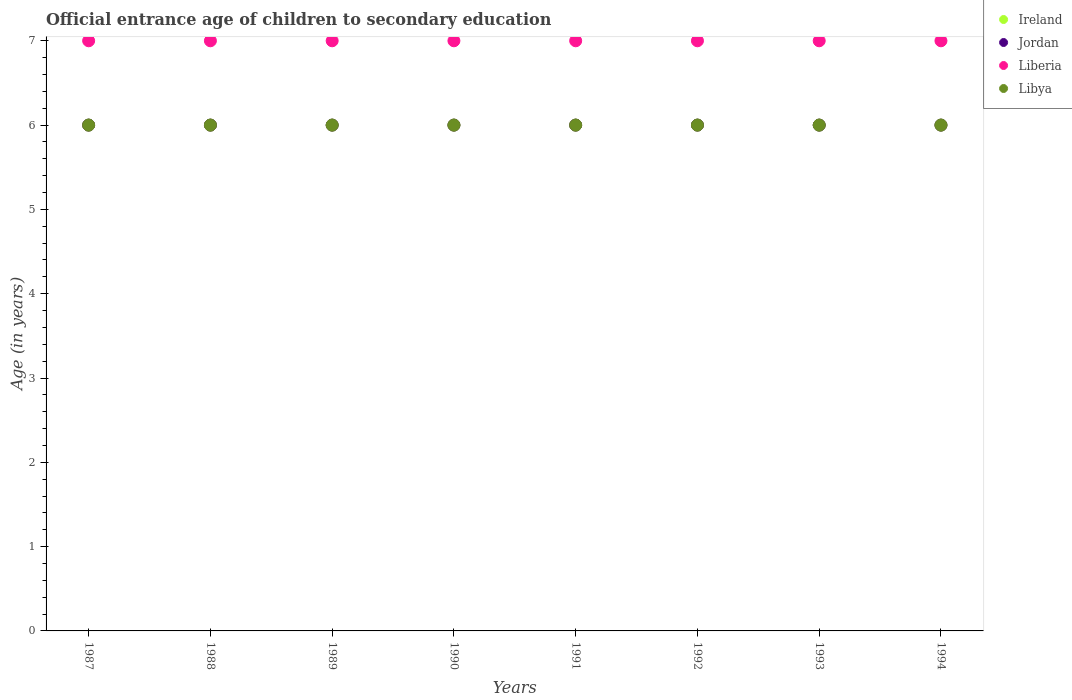What is the secondary school starting age of children in Liberia in 1988?
Provide a succinct answer. 7. Across all years, what is the maximum secondary school starting age of children in Liberia?
Keep it short and to the point. 7. Across all years, what is the minimum secondary school starting age of children in Jordan?
Ensure brevity in your answer.  6. In which year was the secondary school starting age of children in Liberia minimum?
Give a very brief answer. 1987. What is the total secondary school starting age of children in Ireland in the graph?
Make the answer very short. 48. What is the difference between the secondary school starting age of children in Jordan in 1989 and that in 1991?
Offer a very short reply. 0. What is the difference between the secondary school starting age of children in Jordan in 1992 and the secondary school starting age of children in Libya in 1994?
Your answer should be compact. 0. What is the average secondary school starting age of children in Jordan per year?
Your answer should be compact. 6. In the year 1989, what is the difference between the secondary school starting age of children in Jordan and secondary school starting age of children in Ireland?
Ensure brevity in your answer.  0. In how many years, is the secondary school starting age of children in Jordan greater than 4.8 years?
Give a very brief answer. 8. What is the difference between the highest and the lowest secondary school starting age of children in Ireland?
Ensure brevity in your answer.  0. In how many years, is the secondary school starting age of children in Libya greater than the average secondary school starting age of children in Libya taken over all years?
Provide a succinct answer. 0. Is the sum of the secondary school starting age of children in Jordan in 1987 and 1989 greater than the maximum secondary school starting age of children in Liberia across all years?
Provide a short and direct response. Yes. Does the secondary school starting age of children in Libya monotonically increase over the years?
Ensure brevity in your answer.  No. Is the secondary school starting age of children in Libya strictly greater than the secondary school starting age of children in Ireland over the years?
Ensure brevity in your answer.  No. Is the secondary school starting age of children in Jordan strictly less than the secondary school starting age of children in Libya over the years?
Provide a succinct answer. No. How many years are there in the graph?
Offer a very short reply. 8. Are the values on the major ticks of Y-axis written in scientific E-notation?
Keep it short and to the point. No. What is the title of the graph?
Ensure brevity in your answer.  Official entrance age of children to secondary education. Does "Greece" appear as one of the legend labels in the graph?
Provide a short and direct response. No. What is the label or title of the Y-axis?
Provide a short and direct response. Age (in years). What is the Age (in years) of Ireland in 1987?
Provide a short and direct response. 6. What is the Age (in years) in Liberia in 1988?
Your response must be concise. 7. What is the Age (in years) of Ireland in 1989?
Your answer should be very brief. 6. What is the Age (in years) in Liberia in 1990?
Offer a very short reply. 7. What is the Age (in years) in Libya in 1990?
Offer a very short reply. 6. What is the Age (in years) of Ireland in 1991?
Provide a succinct answer. 6. What is the Age (in years) of Liberia in 1991?
Keep it short and to the point. 7. What is the Age (in years) in Ireland in 1992?
Make the answer very short. 6. What is the Age (in years) in Jordan in 1992?
Offer a terse response. 6. What is the Age (in years) of Liberia in 1992?
Your answer should be very brief. 7. What is the Age (in years) in Libya in 1992?
Give a very brief answer. 6. What is the Age (in years) of Jordan in 1993?
Ensure brevity in your answer.  6. What is the Age (in years) in Libya in 1993?
Provide a succinct answer. 6. What is the Age (in years) of Jordan in 1994?
Keep it short and to the point. 6. Across all years, what is the maximum Age (in years) in Ireland?
Offer a terse response. 6. Across all years, what is the maximum Age (in years) of Jordan?
Your answer should be very brief. 6. Across all years, what is the maximum Age (in years) of Libya?
Ensure brevity in your answer.  6. Across all years, what is the minimum Age (in years) in Ireland?
Your answer should be compact. 6. What is the total Age (in years) of Ireland in the graph?
Your answer should be very brief. 48. What is the total Age (in years) of Jordan in the graph?
Make the answer very short. 48. What is the difference between the Age (in years) in Jordan in 1987 and that in 1988?
Keep it short and to the point. 0. What is the difference between the Age (in years) in Libya in 1987 and that in 1988?
Your response must be concise. 0. What is the difference between the Age (in years) of Ireland in 1987 and that in 1989?
Keep it short and to the point. 0. What is the difference between the Age (in years) in Jordan in 1987 and that in 1989?
Ensure brevity in your answer.  0. What is the difference between the Age (in years) of Liberia in 1987 and that in 1990?
Offer a terse response. 0. What is the difference between the Age (in years) of Libya in 1987 and that in 1990?
Offer a very short reply. 0. What is the difference between the Age (in years) in Libya in 1987 and that in 1991?
Your answer should be very brief. 0. What is the difference between the Age (in years) in Jordan in 1987 and that in 1992?
Provide a succinct answer. 0. What is the difference between the Age (in years) of Liberia in 1987 and that in 1992?
Your answer should be very brief. 0. What is the difference between the Age (in years) of Libya in 1987 and that in 1992?
Your response must be concise. 0. What is the difference between the Age (in years) in Jordan in 1987 and that in 1993?
Give a very brief answer. 0. What is the difference between the Age (in years) in Liberia in 1987 and that in 1993?
Your answer should be very brief. 0. What is the difference between the Age (in years) of Libya in 1987 and that in 1993?
Offer a terse response. 0. What is the difference between the Age (in years) in Ireland in 1987 and that in 1994?
Offer a very short reply. 0. What is the difference between the Age (in years) in Liberia in 1988 and that in 1989?
Keep it short and to the point. 0. What is the difference between the Age (in years) in Jordan in 1988 and that in 1990?
Your answer should be very brief. 0. What is the difference between the Age (in years) in Ireland in 1988 and that in 1991?
Keep it short and to the point. 0. What is the difference between the Age (in years) of Libya in 1988 and that in 1991?
Keep it short and to the point. 0. What is the difference between the Age (in years) of Liberia in 1988 and that in 1992?
Your answer should be compact. 0. What is the difference between the Age (in years) in Jordan in 1988 and that in 1993?
Your response must be concise. 0. What is the difference between the Age (in years) of Ireland in 1988 and that in 1994?
Keep it short and to the point. 0. What is the difference between the Age (in years) in Jordan in 1988 and that in 1994?
Give a very brief answer. 0. What is the difference between the Age (in years) in Liberia in 1988 and that in 1994?
Your answer should be very brief. 0. What is the difference between the Age (in years) in Ireland in 1989 and that in 1990?
Keep it short and to the point. 0. What is the difference between the Age (in years) of Jordan in 1989 and that in 1990?
Your answer should be very brief. 0. What is the difference between the Age (in years) of Liberia in 1989 and that in 1990?
Provide a short and direct response. 0. What is the difference between the Age (in years) of Libya in 1989 and that in 1990?
Make the answer very short. 0. What is the difference between the Age (in years) in Jordan in 1989 and that in 1991?
Offer a terse response. 0. What is the difference between the Age (in years) in Ireland in 1989 and that in 1992?
Provide a short and direct response. 0. What is the difference between the Age (in years) of Ireland in 1990 and that in 1991?
Give a very brief answer. 0. What is the difference between the Age (in years) in Ireland in 1990 and that in 1992?
Make the answer very short. 0. What is the difference between the Age (in years) in Liberia in 1990 and that in 1992?
Offer a very short reply. 0. What is the difference between the Age (in years) in Jordan in 1990 and that in 1993?
Offer a very short reply. 0. What is the difference between the Age (in years) in Ireland in 1990 and that in 1994?
Give a very brief answer. 0. What is the difference between the Age (in years) in Liberia in 1991 and that in 1992?
Make the answer very short. 0. What is the difference between the Age (in years) of Ireland in 1991 and that in 1994?
Your answer should be compact. 0. What is the difference between the Age (in years) of Liberia in 1991 and that in 1994?
Provide a succinct answer. 0. What is the difference between the Age (in years) in Ireland in 1992 and that in 1993?
Ensure brevity in your answer.  0. What is the difference between the Age (in years) in Jordan in 1992 and that in 1994?
Offer a terse response. 0. What is the difference between the Age (in years) in Libya in 1992 and that in 1994?
Your answer should be very brief. 0. What is the difference between the Age (in years) of Liberia in 1993 and that in 1994?
Provide a short and direct response. 0. What is the difference between the Age (in years) of Ireland in 1987 and the Age (in years) of Jordan in 1988?
Provide a short and direct response. 0. What is the difference between the Age (in years) in Jordan in 1987 and the Age (in years) in Liberia in 1988?
Your response must be concise. -1. What is the difference between the Age (in years) of Jordan in 1987 and the Age (in years) of Libya in 1988?
Offer a terse response. 0. What is the difference between the Age (in years) of Ireland in 1987 and the Age (in years) of Liberia in 1989?
Give a very brief answer. -1. What is the difference between the Age (in years) of Ireland in 1987 and the Age (in years) of Libya in 1989?
Ensure brevity in your answer.  0. What is the difference between the Age (in years) in Jordan in 1987 and the Age (in years) in Liberia in 1989?
Your answer should be compact. -1. What is the difference between the Age (in years) of Jordan in 1987 and the Age (in years) of Liberia in 1990?
Your response must be concise. -1. What is the difference between the Age (in years) in Jordan in 1987 and the Age (in years) in Libya in 1990?
Offer a very short reply. 0. What is the difference between the Age (in years) in Liberia in 1987 and the Age (in years) in Libya in 1990?
Keep it short and to the point. 1. What is the difference between the Age (in years) of Ireland in 1987 and the Age (in years) of Jordan in 1991?
Give a very brief answer. 0. What is the difference between the Age (in years) of Ireland in 1987 and the Age (in years) of Libya in 1991?
Your answer should be very brief. 0. What is the difference between the Age (in years) of Jordan in 1987 and the Age (in years) of Liberia in 1991?
Make the answer very short. -1. What is the difference between the Age (in years) in Jordan in 1987 and the Age (in years) in Libya in 1991?
Your response must be concise. 0. What is the difference between the Age (in years) in Liberia in 1987 and the Age (in years) in Libya in 1991?
Your answer should be very brief. 1. What is the difference between the Age (in years) in Ireland in 1987 and the Age (in years) in Liberia in 1992?
Your answer should be compact. -1. What is the difference between the Age (in years) in Liberia in 1987 and the Age (in years) in Libya in 1992?
Offer a terse response. 1. What is the difference between the Age (in years) in Ireland in 1987 and the Age (in years) in Liberia in 1993?
Give a very brief answer. -1. What is the difference between the Age (in years) of Ireland in 1987 and the Age (in years) of Libya in 1993?
Ensure brevity in your answer.  0. What is the difference between the Age (in years) in Jordan in 1987 and the Age (in years) in Liberia in 1993?
Give a very brief answer. -1. What is the difference between the Age (in years) of Ireland in 1987 and the Age (in years) of Jordan in 1994?
Make the answer very short. 0. What is the difference between the Age (in years) of Ireland in 1987 and the Age (in years) of Liberia in 1994?
Provide a succinct answer. -1. What is the difference between the Age (in years) of Ireland in 1987 and the Age (in years) of Libya in 1994?
Ensure brevity in your answer.  0. What is the difference between the Age (in years) in Jordan in 1987 and the Age (in years) in Libya in 1994?
Provide a short and direct response. 0. What is the difference between the Age (in years) in Ireland in 1988 and the Age (in years) in Liberia in 1989?
Provide a succinct answer. -1. What is the difference between the Age (in years) in Ireland in 1988 and the Age (in years) in Libya in 1989?
Keep it short and to the point. 0. What is the difference between the Age (in years) of Jordan in 1988 and the Age (in years) of Libya in 1989?
Offer a terse response. 0. What is the difference between the Age (in years) in Liberia in 1988 and the Age (in years) in Libya in 1989?
Keep it short and to the point. 1. What is the difference between the Age (in years) of Ireland in 1988 and the Age (in years) of Jordan in 1990?
Your answer should be very brief. 0. What is the difference between the Age (in years) in Ireland in 1988 and the Age (in years) in Libya in 1990?
Make the answer very short. 0. What is the difference between the Age (in years) of Jordan in 1988 and the Age (in years) of Liberia in 1990?
Your answer should be very brief. -1. What is the difference between the Age (in years) of Jordan in 1988 and the Age (in years) of Libya in 1990?
Provide a short and direct response. 0. What is the difference between the Age (in years) of Ireland in 1988 and the Age (in years) of Jordan in 1991?
Offer a very short reply. 0. What is the difference between the Age (in years) in Ireland in 1988 and the Age (in years) in Liberia in 1991?
Give a very brief answer. -1. What is the difference between the Age (in years) in Ireland in 1988 and the Age (in years) in Libya in 1991?
Your response must be concise. 0. What is the difference between the Age (in years) of Jordan in 1988 and the Age (in years) of Liberia in 1991?
Your response must be concise. -1. What is the difference between the Age (in years) of Jordan in 1988 and the Age (in years) of Libya in 1991?
Offer a terse response. 0. What is the difference between the Age (in years) of Liberia in 1988 and the Age (in years) of Libya in 1991?
Offer a very short reply. 1. What is the difference between the Age (in years) of Jordan in 1988 and the Age (in years) of Liberia in 1992?
Provide a short and direct response. -1. What is the difference between the Age (in years) in Jordan in 1988 and the Age (in years) in Libya in 1992?
Offer a terse response. 0. What is the difference between the Age (in years) of Ireland in 1988 and the Age (in years) of Liberia in 1993?
Your answer should be compact. -1. What is the difference between the Age (in years) of Ireland in 1988 and the Age (in years) of Liberia in 1994?
Your response must be concise. -1. What is the difference between the Age (in years) in Ireland in 1988 and the Age (in years) in Libya in 1994?
Ensure brevity in your answer.  0. What is the difference between the Age (in years) in Jordan in 1988 and the Age (in years) in Liberia in 1994?
Your answer should be compact. -1. What is the difference between the Age (in years) in Jordan in 1988 and the Age (in years) in Libya in 1994?
Provide a short and direct response. 0. What is the difference between the Age (in years) of Liberia in 1988 and the Age (in years) of Libya in 1994?
Keep it short and to the point. 1. What is the difference between the Age (in years) of Ireland in 1989 and the Age (in years) of Jordan in 1990?
Provide a succinct answer. 0. What is the difference between the Age (in years) of Ireland in 1989 and the Age (in years) of Liberia in 1990?
Offer a terse response. -1. What is the difference between the Age (in years) in Ireland in 1989 and the Age (in years) in Libya in 1990?
Your answer should be very brief. 0. What is the difference between the Age (in years) in Jordan in 1989 and the Age (in years) in Liberia in 1990?
Your answer should be compact. -1. What is the difference between the Age (in years) of Jordan in 1989 and the Age (in years) of Libya in 1990?
Offer a terse response. 0. What is the difference between the Age (in years) in Jordan in 1989 and the Age (in years) in Libya in 1991?
Offer a terse response. 0. What is the difference between the Age (in years) of Ireland in 1989 and the Age (in years) of Libya in 1992?
Your response must be concise. 0. What is the difference between the Age (in years) of Jordan in 1989 and the Age (in years) of Libya in 1992?
Offer a terse response. 0. What is the difference between the Age (in years) of Ireland in 1989 and the Age (in years) of Liberia in 1993?
Your answer should be very brief. -1. What is the difference between the Age (in years) in Jordan in 1989 and the Age (in years) in Liberia in 1993?
Provide a succinct answer. -1. What is the difference between the Age (in years) of Jordan in 1989 and the Age (in years) of Libya in 1993?
Provide a short and direct response. 0. What is the difference between the Age (in years) in Liberia in 1989 and the Age (in years) in Libya in 1993?
Give a very brief answer. 1. What is the difference between the Age (in years) in Ireland in 1989 and the Age (in years) in Jordan in 1994?
Ensure brevity in your answer.  0. What is the difference between the Age (in years) of Jordan in 1989 and the Age (in years) of Liberia in 1994?
Offer a very short reply. -1. What is the difference between the Age (in years) of Ireland in 1990 and the Age (in years) of Liberia in 1991?
Offer a very short reply. -1. What is the difference between the Age (in years) in Jordan in 1990 and the Age (in years) in Libya in 1991?
Make the answer very short. 0. What is the difference between the Age (in years) in Ireland in 1990 and the Age (in years) in Jordan in 1992?
Offer a terse response. 0. What is the difference between the Age (in years) in Ireland in 1990 and the Age (in years) in Libya in 1992?
Your response must be concise. 0. What is the difference between the Age (in years) of Jordan in 1990 and the Age (in years) of Liberia in 1992?
Provide a short and direct response. -1. What is the difference between the Age (in years) in Jordan in 1990 and the Age (in years) in Libya in 1992?
Provide a short and direct response. 0. What is the difference between the Age (in years) in Ireland in 1990 and the Age (in years) in Liberia in 1993?
Your answer should be compact. -1. What is the difference between the Age (in years) of Jordan in 1990 and the Age (in years) of Liberia in 1993?
Ensure brevity in your answer.  -1. What is the difference between the Age (in years) in Liberia in 1990 and the Age (in years) in Libya in 1993?
Your response must be concise. 1. What is the difference between the Age (in years) of Ireland in 1990 and the Age (in years) of Liberia in 1994?
Your answer should be very brief. -1. What is the difference between the Age (in years) in Ireland in 1990 and the Age (in years) in Libya in 1994?
Make the answer very short. 0. What is the difference between the Age (in years) in Jordan in 1990 and the Age (in years) in Liberia in 1994?
Your response must be concise. -1. What is the difference between the Age (in years) in Jordan in 1991 and the Age (in years) in Libya in 1992?
Make the answer very short. 0. What is the difference between the Age (in years) in Liberia in 1991 and the Age (in years) in Libya in 1992?
Provide a short and direct response. 1. What is the difference between the Age (in years) of Jordan in 1991 and the Age (in years) of Libya in 1993?
Make the answer very short. 0. What is the difference between the Age (in years) of Liberia in 1991 and the Age (in years) of Libya in 1993?
Ensure brevity in your answer.  1. What is the difference between the Age (in years) of Ireland in 1991 and the Age (in years) of Jordan in 1994?
Ensure brevity in your answer.  0. What is the difference between the Age (in years) of Jordan in 1991 and the Age (in years) of Liberia in 1994?
Provide a succinct answer. -1. What is the difference between the Age (in years) in Jordan in 1991 and the Age (in years) in Libya in 1994?
Your answer should be compact. 0. What is the difference between the Age (in years) of Liberia in 1991 and the Age (in years) of Libya in 1994?
Offer a terse response. 1. What is the difference between the Age (in years) in Ireland in 1992 and the Age (in years) in Jordan in 1993?
Ensure brevity in your answer.  0. What is the difference between the Age (in years) in Ireland in 1992 and the Age (in years) in Libya in 1993?
Your answer should be compact. 0. What is the difference between the Age (in years) of Jordan in 1992 and the Age (in years) of Liberia in 1993?
Provide a succinct answer. -1. What is the difference between the Age (in years) in Liberia in 1992 and the Age (in years) in Libya in 1993?
Your answer should be very brief. 1. What is the difference between the Age (in years) in Ireland in 1992 and the Age (in years) in Jordan in 1994?
Your answer should be compact. 0. What is the difference between the Age (in years) in Ireland in 1992 and the Age (in years) in Liberia in 1994?
Your response must be concise. -1. What is the difference between the Age (in years) of Ireland in 1993 and the Age (in years) of Liberia in 1994?
Offer a very short reply. -1. What is the difference between the Age (in years) of Jordan in 1993 and the Age (in years) of Libya in 1994?
Make the answer very short. 0. What is the difference between the Age (in years) of Liberia in 1993 and the Age (in years) of Libya in 1994?
Give a very brief answer. 1. What is the average Age (in years) of Liberia per year?
Ensure brevity in your answer.  7. What is the average Age (in years) of Libya per year?
Offer a terse response. 6. In the year 1987, what is the difference between the Age (in years) of Ireland and Age (in years) of Libya?
Ensure brevity in your answer.  0. In the year 1987, what is the difference between the Age (in years) of Jordan and Age (in years) of Liberia?
Provide a short and direct response. -1. In the year 1987, what is the difference between the Age (in years) of Jordan and Age (in years) of Libya?
Make the answer very short. 0. In the year 1988, what is the difference between the Age (in years) of Ireland and Age (in years) of Liberia?
Provide a short and direct response. -1. In the year 1988, what is the difference between the Age (in years) in Ireland and Age (in years) in Libya?
Your answer should be compact. 0. In the year 1988, what is the difference between the Age (in years) in Liberia and Age (in years) in Libya?
Your answer should be very brief. 1. In the year 1989, what is the difference between the Age (in years) in Jordan and Age (in years) in Liberia?
Your response must be concise. -1. In the year 1989, what is the difference between the Age (in years) of Jordan and Age (in years) of Libya?
Keep it short and to the point. 0. In the year 1990, what is the difference between the Age (in years) of Ireland and Age (in years) of Jordan?
Make the answer very short. 0. In the year 1990, what is the difference between the Age (in years) in Jordan and Age (in years) in Liberia?
Provide a short and direct response. -1. In the year 1990, what is the difference between the Age (in years) in Jordan and Age (in years) in Libya?
Your answer should be very brief. 0. In the year 1990, what is the difference between the Age (in years) of Liberia and Age (in years) of Libya?
Your answer should be compact. 1. In the year 1991, what is the difference between the Age (in years) in Ireland and Age (in years) in Liberia?
Offer a terse response. -1. In the year 1991, what is the difference between the Age (in years) of Ireland and Age (in years) of Libya?
Offer a very short reply. 0. In the year 1992, what is the difference between the Age (in years) in Ireland and Age (in years) in Jordan?
Offer a terse response. 0. In the year 1992, what is the difference between the Age (in years) in Jordan and Age (in years) in Liberia?
Give a very brief answer. -1. In the year 1992, what is the difference between the Age (in years) of Liberia and Age (in years) of Libya?
Make the answer very short. 1. In the year 1993, what is the difference between the Age (in years) of Ireland and Age (in years) of Liberia?
Offer a very short reply. -1. In the year 1993, what is the difference between the Age (in years) of Jordan and Age (in years) of Liberia?
Make the answer very short. -1. In the year 1993, what is the difference between the Age (in years) in Jordan and Age (in years) in Libya?
Offer a terse response. 0. In the year 1993, what is the difference between the Age (in years) in Liberia and Age (in years) in Libya?
Offer a terse response. 1. In the year 1994, what is the difference between the Age (in years) of Ireland and Age (in years) of Jordan?
Your answer should be very brief. 0. In the year 1994, what is the difference between the Age (in years) in Ireland and Age (in years) in Liberia?
Your response must be concise. -1. In the year 1994, what is the difference between the Age (in years) of Ireland and Age (in years) of Libya?
Ensure brevity in your answer.  0. In the year 1994, what is the difference between the Age (in years) in Jordan and Age (in years) in Liberia?
Your response must be concise. -1. In the year 1994, what is the difference between the Age (in years) of Liberia and Age (in years) of Libya?
Your answer should be very brief. 1. What is the ratio of the Age (in years) of Ireland in 1987 to that in 1988?
Offer a very short reply. 1. What is the ratio of the Age (in years) in Jordan in 1987 to that in 1988?
Your answer should be very brief. 1. What is the ratio of the Age (in years) of Liberia in 1987 to that in 1988?
Your answer should be compact. 1. What is the ratio of the Age (in years) of Ireland in 1987 to that in 1990?
Make the answer very short. 1. What is the ratio of the Age (in years) in Libya in 1987 to that in 1990?
Keep it short and to the point. 1. What is the ratio of the Age (in years) of Liberia in 1987 to that in 1991?
Ensure brevity in your answer.  1. What is the ratio of the Age (in years) of Libya in 1987 to that in 1991?
Your answer should be very brief. 1. What is the ratio of the Age (in years) in Ireland in 1987 to that in 1992?
Provide a succinct answer. 1. What is the ratio of the Age (in years) in Jordan in 1987 to that in 1992?
Ensure brevity in your answer.  1. What is the ratio of the Age (in years) of Liberia in 1987 to that in 1992?
Provide a succinct answer. 1. What is the ratio of the Age (in years) of Ireland in 1987 to that in 1993?
Give a very brief answer. 1. What is the ratio of the Age (in years) of Jordan in 1987 to that in 1993?
Offer a very short reply. 1. What is the ratio of the Age (in years) of Liberia in 1987 to that in 1993?
Ensure brevity in your answer.  1. What is the ratio of the Age (in years) of Liberia in 1987 to that in 1994?
Offer a very short reply. 1. What is the ratio of the Age (in years) of Ireland in 1988 to that in 1989?
Offer a terse response. 1. What is the ratio of the Age (in years) of Jordan in 1988 to that in 1989?
Offer a very short reply. 1. What is the ratio of the Age (in years) of Liberia in 1988 to that in 1989?
Your answer should be very brief. 1. What is the ratio of the Age (in years) in Libya in 1988 to that in 1989?
Give a very brief answer. 1. What is the ratio of the Age (in years) in Ireland in 1988 to that in 1990?
Keep it short and to the point. 1. What is the ratio of the Age (in years) in Ireland in 1988 to that in 1991?
Keep it short and to the point. 1. What is the ratio of the Age (in years) in Liberia in 1988 to that in 1991?
Give a very brief answer. 1. What is the ratio of the Age (in years) of Ireland in 1988 to that in 1992?
Give a very brief answer. 1. What is the ratio of the Age (in years) of Jordan in 1988 to that in 1992?
Provide a short and direct response. 1. What is the ratio of the Age (in years) in Liberia in 1988 to that in 1992?
Your answer should be very brief. 1. What is the ratio of the Age (in years) of Libya in 1988 to that in 1993?
Give a very brief answer. 1. What is the ratio of the Age (in years) of Liberia in 1988 to that in 1994?
Give a very brief answer. 1. What is the ratio of the Age (in years) in Libya in 1988 to that in 1994?
Offer a very short reply. 1. What is the ratio of the Age (in years) of Ireland in 1989 to that in 1990?
Ensure brevity in your answer.  1. What is the ratio of the Age (in years) in Jordan in 1989 to that in 1990?
Your answer should be compact. 1. What is the ratio of the Age (in years) in Ireland in 1989 to that in 1991?
Make the answer very short. 1. What is the ratio of the Age (in years) of Jordan in 1989 to that in 1991?
Offer a very short reply. 1. What is the ratio of the Age (in years) in Liberia in 1989 to that in 1991?
Your answer should be very brief. 1. What is the ratio of the Age (in years) in Libya in 1989 to that in 1991?
Your answer should be compact. 1. What is the ratio of the Age (in years) in Ireland in 1989 to that in 1992?
Your answer should be compact. 1. What is the ratio of the Age (in years) of Libya in 1989 to that in 1992?
Ensure brevity in your answer.  1. What is the ratio of the Age (in years) of Ireland in 1989 to that in 1993?
Your answer should be very brief. 1. What is the ratio of the Age (in years) in Jordan in 1989 to that in 1993?
Provide a succinct answer. 1. What is the ratio of the Age (in years) in Liberia in 1989 to that in 1993?
Ensure brevity in your answer.  1. What is the ratio of the Age (in years) of Libya in 1989 to that in 1993?
Make the answer very short. 1. What is the ratio of the Age (in years) in Ireland in 1989 to that in 1994?
Your response must be concise. 1. What is the ratio of the Age (in years) in Jordan in 1989 to that in 1994?
Ensure brevity in your answer.  1. What is the ratio of the Age (in years) in Liberia in 1989 to that in 1994?
Offer a terse response. 1. What is the ratio of the Age (in years) of Ireland in 1990 to that in 1991?
Make the answer very short. 1. What is the ratio of the Age (in years) of Jordan in 1990 to that in 1991?
Your answer should be compact. 1. What is the ratio of the Age (in years) in Liberia in 1990 to that in 1991?
Offer a very short reply. 1. What is the ratio of the Age (in years) in Jordan in 1990 to that in 1992?
Offer a terse response. 1. What is the ratio of the Age (in years) of Liberia in 1990 to that in 1992?
Provide a short and direct response. 1. What is the ratio of the Age (in years) in Libya in 1990 to that in 1992?
Provide a succinct answer. 1. What is the ratio of the Age (in years) in Libya in 1990 to that in 1993?
Keep it short and to the point. 1. What is the ratio of the Age (in years) of Jordan in 1990 to that in 1994?
Your answer should be very brief. 1. What is the ratio of the Age (in years) in Liberia in 1990 to that in 1994?
Provide a succinct answer. 1. What is the ratio of the Age (in years) of Libya in 1990 to that in 1994?
Provide a succinct answer. 1. What is the ratio of the Age (in years) in Liberia in 1991 to that in 1992?
Make the answer very short. 1. What is the ratio of the Age (in years) of Libya in 1991 to that in 1992?
Your answer should be compact. 1. What is the ratio of the Age (in years) in Ireland in 1991 to that in 1993?
Give a very brief answer. 1. What is the ratio of the Age (in years) in Jordan in 1991 to that in 1993?
Make the answer very short. 1. What is the ratio of the Age (in years) of Liberia in 1991 to that in 1993?
Ensure brevity in your answer.  1. What is the ratio of the Age (in years) in Libya in 1991 to that in 1993?
Offer a terse response. 1. What is the ratio of the Age (in years) in Jordan in 1991 to that in 1994?
Offer a very short reply. 1. What is the ratio of the Age (in years) of Libya in 1991 to that in 1994?
Keep it short and to the point. 1. What is the ratio of the Age (in years) of Ireland in 1992 to that in 1993?
Provide a succinct answer. 1. What is the ratio of the Age (in years) in Jordan in 1992 to that in 1993?
Ensure brevity in your answer.  1. What is the ratio of the Age (in years) in Liberia in 1992 to that in 1993?
Your answer should be compact. 1. What is the ratio of the Age (in years) in Ireland in 1992 to that in 1994?
Offer a terse response. 1. What is the ratio of the Age (in years) of Liberia in 1992 to that in 1994?
Your answer should be very brief. 1. What is the ratio of the Age (in years) of Jordan in 1993 to that in 1994?
Make the answer very short. 1. What is the difference between the highest and the second highest Age (in years) in Ireland?
Your response must be concise. 0. What is the difference between the highest and the second highest Age (in years) in Jordan?
Offer a terse response. 0. What is the difference between the highest and the second highest Age (in years) in Liberia?
Offer a very short reply. 0. What is the difference between the highest and the lowest Age (in years) of Jordan?
Give a very brief answer. 0. What is the difference between the highest and the lowest Age (in years) of Liberia?
Your answer should be compact. 0. 